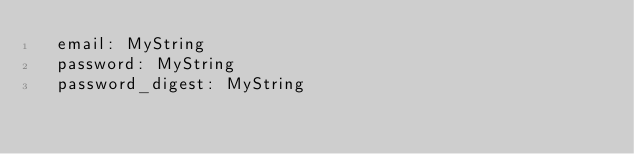Convert code to text. <code><loc_0><loc_0><loc_500><loc_500><_YAML_>  email: MyString
  password: MyString
  password_digest: MyString
</code> 